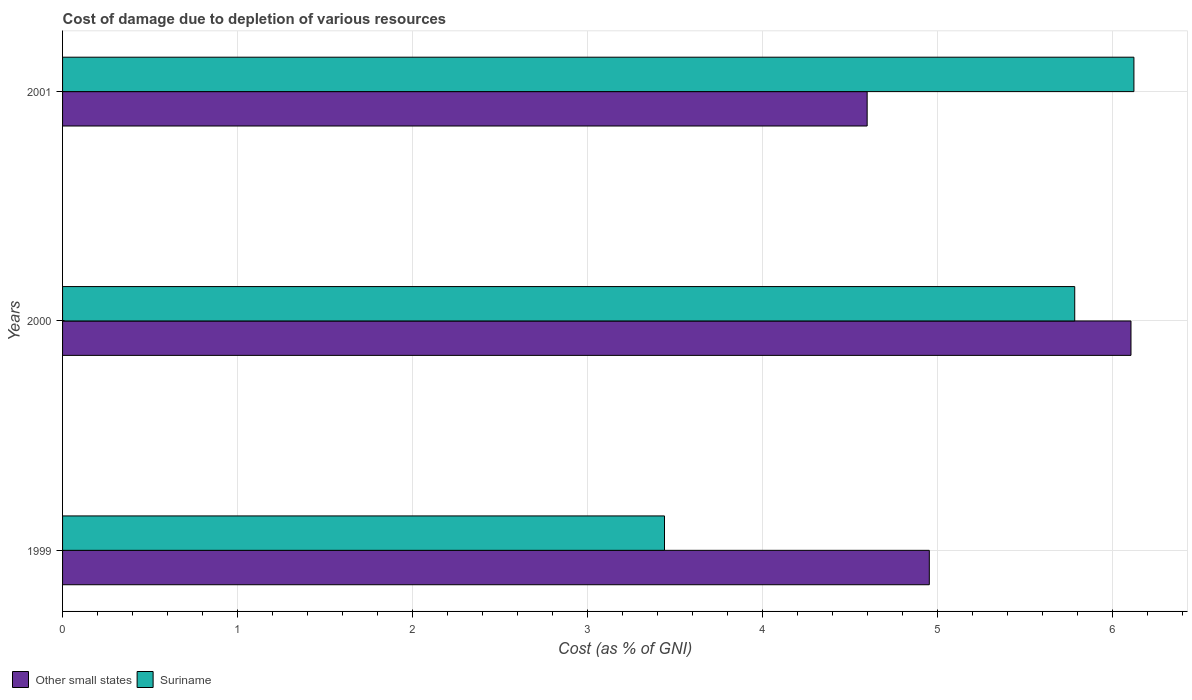How many different coloured bars are there?
Provide a short and direct response. 2. Are the number of bars per tick equal to the number of legend labels?
Your response must be concise. Yes. Are the number of bars on each tick of the Y-axis equal?
Your response must be concise. Yes. What is the label of the 2nd group of bars from the top?
Make the answer very short. 2000. What is the cost of damage caused due to the depletion of various resources in Other small states in 2000?
Ensure brevity in your answer.  6.11. Across all years, what is the maximum cost of damage caused due to the depletion of various resources in Suriname?
Offer a very short reply. 6.12. Across all years, what is the minimum cost of damage caused due to the depletion of various resources in Suriname?
Ensure brevity in your answer.  3.44. In which year was the cost of damage caused due to the depletion of various resources in Other small states maximum?
Make the answer very short. 2000. What is the total cost of damage caused due to the depletion of various resources in Suriname in the graph?
Give a very brief answer. 15.35. What is the difference between the cost of damage caused due to the depletion of various resources in Suriname in 1999 and that in 2001?
Offer a very short reply. -2.68. What is the difference between the cost of damage caused due to the depletion of various resources in Suriname in 2000 and the cost of damage caused due to the depletion of various resources in Other small states in 1999?
Provide a short and direct response. 0.83. What is the average cost of damage caused due to the depletion of various resources in Suriname per year?
Offer a very short reply. 5.12. In the year 1999, what is the difference between the cost of damage caused due to the depletion of various resources in Suriname and cost of damage caused due to the depletion of various resources in Other small states?
Your response must be concise. -1.51. What is the ratio of the cost of damage caused due to the depletion of various resources in Suriname in 2000 to that in 2001?
Your answer should be very brief. 0.94. Is the cost of damage caused due to the depletion of various resources in Other small states in 1999 less than that in 2001?
Give a very brief answer. No. What is the difference between the highest and the second highest cost of damage caused due to the depletion of various resources in Suriname?
Offer a terse response. 0.34. What is the difference between the highest and the lowest cost of damage caused due to the depletion of various resources in Other small states?
Offer a very short reply. 1.51. Is the sum of the cost of damage caused due to the depletion of various resources in Other small states in 2000 and 2001 greater than the maximum cost of damage caused due to the depletion of various resources in Suriname across all years?
Ensure brevity in your answer.  Yes. What does the 2nd bar from the top in 1999 represents?
Your answer should be very brief. Other small states. What does the 2nd bar from the bottom in 2001 represents?
Your response must be concise. Suriname. How many bars are there?
Keep it short and to the point. 6. How many years are there in the graph?
Provide a succinct answer. 3. What is the difference between two consecutive major ticks on the X-axis?
Give a very brief answer. 1. Are the values on the major ticks of X-axis written in scientific E-notation?
Offer a terse response. No. Does the graph contain any zero values?
Keep it short and to the point. No. How many legend labels are there?
Your response must be concise. 2. How are the legend labels stacked?
Ensure brevity in your answer.  Horizontal. What is the title of the graph?
Offer a terse response. Cost of damage due to depletion of various resources. Does "Andorra" appear as one of the legend labels in the graph?
Give a very brief answer. No. What is the label or title of the X-axis?
Make the answer very short. Cost (as % of GNI). What is the label or title of the Y-axis?
Offer a terse response. Years. What is the Cost (as % of GNI) of Other small states in 1999?
Keep it short and to the point. 4.95. What is the Cost (as % of GNI) of Suriname in 1999?
Keep it short and to the point. 3.44. What is the Cost (as % of GNI) in Other small states in 2000?
Provide a succinct answer. 6.11. What is the Cost (as % of GNI) of Suriname in 2000?
Provide a succinct answer. 5.78. What is the Cost (as % of GNI) in Other small states in 2001?
Your answer should be compact. 4.6. What is the Cost (as % of GNI) in Suriname in 2001?
Offer a terse response. 6.12. Across all years, what is the maximum Cost (as % of GNI) in Other small states?
Provide a succinct answer. 6.11. Across all years, what is the maximum Cost (as % of GNI) in Suriname?
Make the answer very short. 6.12. Across all years, what is the minimum Cost (as % of GNI) in Other small states?
Make the answer very short. 4.6. Across all years, what is the minimum Cost (as % of GNI) of Suriname?
Your answer should be very brief. 3.44. What is the total Cost (as % of GNI) in Other small states in the graph?
Your response must be concise. 15.66. What is the total Cost (as % of GNI) of Suriname in the graph?
Offer a terse response. 15.35. What is the difference between the Cost (as % of GNI) of Other small states in 1999 and that in 2000?
Provide a short and direct response. -1.15. What is the difference between the Cost (as % of GNI) of Suriname in 1999 and that in 2000?
Give a very brief answer. -2.34. What is the difference between the Cost (as % of GNI) in Other small states in 1999 and that in 2001?
Ensure brevity in your answer.  0.36. What is the difference between the Cost (as % of GNI) in Suriname in 1999 and that in 2001?
Provide a succinct answer. -2.68. What is the difference between the Cost (as % of GNI) in Other small states in 2000 and that in 2001?
Make the answer very short. 1.51. What is the difference between the Cost (as % of GNI) in Suriname in 2000 and that in 2001?
Give a very brief answer. -0.34. What is the difference between the Cost (as % of GNI) in Other small states in 1999 and the Cost (as % of GNI) in Suriname in 2000?
Offer a very short reply. -0.83. What is the difference between the Cost (as % of GNI) of Other small states in 1999 and the Cost (as % of GNI) of Suriname in 2001?
Offer a very short reply. -1.17. What is the difference between the Cost (as % of GNI) in Other small states in 2000 and the Cost (as % of GNI) in Suriname in 2001?
Ensure brevity in your answer.  -0.02. What is the average Cost (as % of GNI) of Other small states per year?
Your answer should be very brief. 5.22. What is the average Cost (as % of GNI) in Suriname per year?
Your answer should be compact. 5.12. In the year 1999, what is the difference between the Cost (as % of GNI) of Other small states and Cost (as % of GNI) of Suriname?
Provide a succinct answer. 1.51. In the year 2000, what is the difference between the Cost (as % of GNI) in Other small states and Cost (as % of GNI) in Suriname?
Offer a very short reply. 0.32. In the year 2001, what is the difference between the Cost (as % of GNI) in Other small states and Cost (as % of GNI) in Suriname?
Ensure brevity in your answer.  -1.52. What is the ratio of the Cost (as % of GNI) in Other small states in 1999 to that in 2000?
Give a very brief answer. 0.81. What is the ratio of the Cost (as % of GNI) of Suriname in 1999 to that in 2000?
Provide a short and direct response. 0.59. What is the ratio of the Cost (as % of GNI) of Other small states in 1999 to that in 2001?
Make the answer very short. 1.08. What is the ratio of the Cost (as % of GNI) in Suriname in 1999 to that in 2001?
Ensure brevity in your answer.  0.56. What is the ratio of the Cost (as % of GNI) of Other small states in 2000 to that in 2001?
Provide a short and direct response. 1.33. What is the ratio of the Cost (as % of GNI) in Suriname in 2000 to that in 2001?
Give a very brief answer. 0.94. What is the difference between the highest and the second highest Cost (as % of GNI) of Other small states?
Your answer should be compact. 1.15. What is the difference between the highest and the second highest Cost (as % of GNI) of Suriname?
Give a very brief answer. 0.34. What is the difference between the highest and the lowest Cost (as % of GNI) of Other small states?
Your answer should be compact. 1.51. What is the difference between the highest and the lowest Cost (as % of GNI) of Suriname?
Provide a succinct answer. 2.68. 